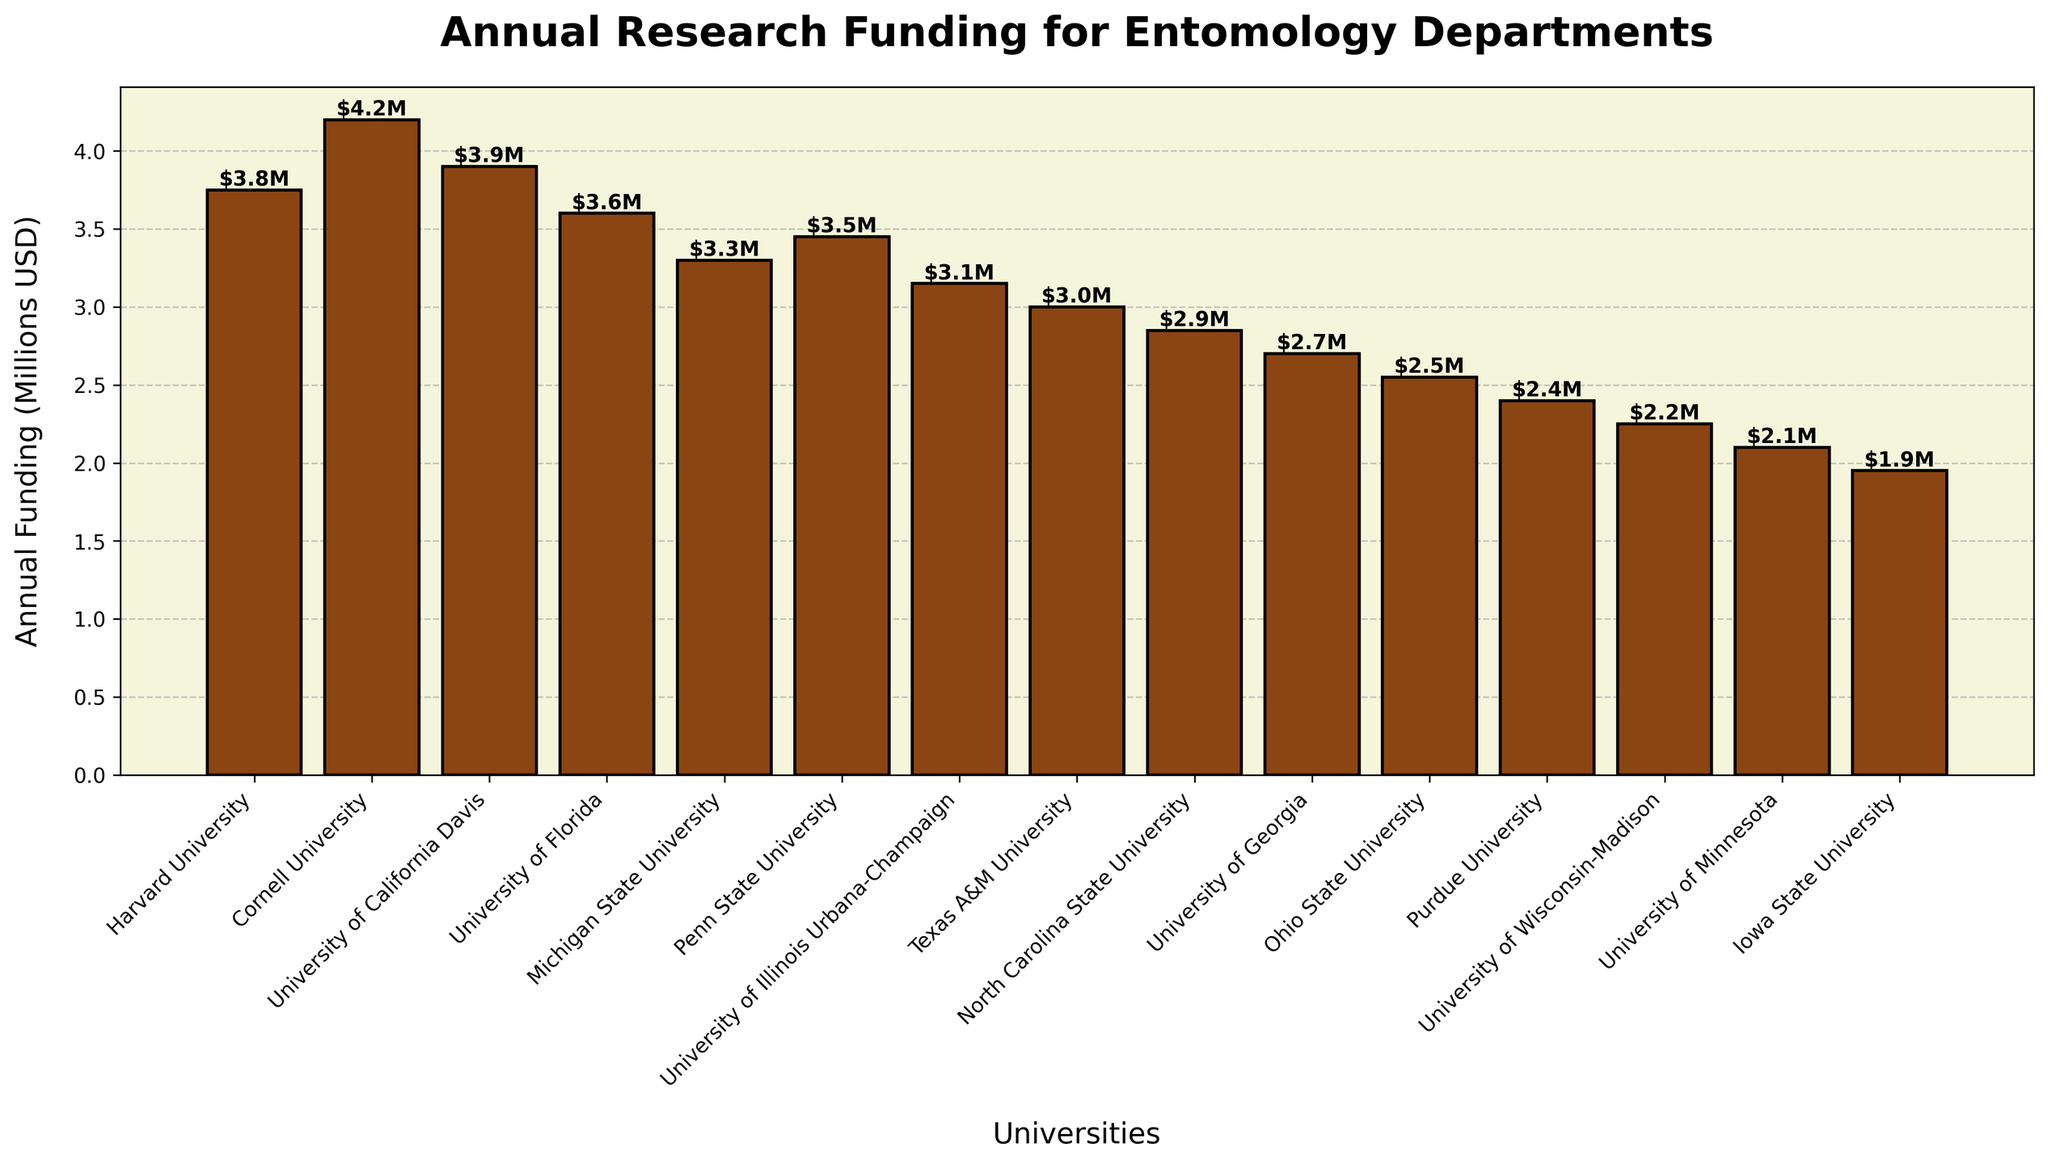How many universities have annual research funding greater than $3 million? Look at the bars that represent each university's funding. Count the number of bars that are labeled above $3 million. Harvard, Cornell, UC Davis, Florida, Michigan State, and Penn State all have funding greater than $3 million.
Answer: 6 Which university has the least research funding? Look at the height of the bars. The shortest bar represents the university with the least funding. The University of Minnesota has the shortest bar.
Answer: University of Minnesota What is the total annual research funding for the top 3 universities? Identify the top 3 universities by height: Cornell, UC Davis, and Harvard. Sum their annual research funding values (4.2M + 3.9M + 3.75M).
Answer: $11.85M Which university receives $3 Million in annual research funding? Look at the labels on top of the bars to identify the one with $3M. Texas A&M University receives $3M in funding.
Answer: Texas A&M University How much more funding does Cornell University receive compared to the University of Florida? Check the labels for Cornell and Florida. Subtract Florida's funding from Cornell's funding (4.2M - 3.6M).
Answer: $0.6M What is the average annual research funding for all universities? Sum all the funding values and divide by the number of universities. (37.5M + 42M + 39M + 36M + 33M + 34.5M + 31.5M + 30M + 28.5M + 27M + 25.5M + 24M + 22.5M + 21M + 19.5M)/15
Answer: $31.27M Is there any university with exactly $3.45 million in annual research funding? Look at the labels on top of the bars and identify if any bar has exactly the label $3.45M. Penn State University has a label of $3.45M.
Answer: Yes What is the funding difference between the university with the highest and the lowest research funding? Identify the highest and lowest funding amounts (Cornell's $4.2M and Minnesota's $2.1M). Subtract the lowest from the highest (4.2M - 2.1M).
Answer: $2.1M Which universities have research funding less than $3 million? Identify the bars with labels indicating funding amounts less than $3M: North Carolina State University, University of Georgia, Ohio State University, Purdue University, University of Wisconsin-Madison, University of Minnesota, and Iowa State University.
Answer: 7 universities 